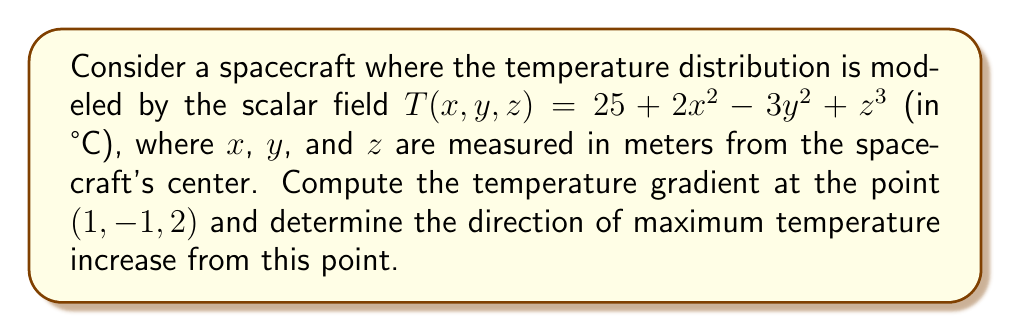Show me your answer to this math problem. To solve this problem, we'll follow these steps:

1) The gradient of a scalar field $T(x,y,z)$ is defined as:

   $$\nabla T = \left(\frac{\partial T}{\partial x}, \frac{\partial T}{\partial y}, \frac{\partial T}{\partial z}\right)$$

2) Let's compute each partial derivative:

   $$\frac{\partial T}{\partial x} = 4x$$
   $$\frac{\partial T}{\partial y} = -6y$$
   $$\frac{\partial T}{\partial z} = 3z^2$$

3) Now, we can form the gradient:

   $$\nabla T = (4x, -6y, 3z^2)$$

4) At the point (1, -1, 2), we have:

   $$\nabla T(1,-1,2) = (4(1), -6(-1), 3(2)^2) = (4, 6, 12)$$

5) This gradient vector points in the direction of maximum temperature increase. To get a unit vector in this direction, we normalize the gradient:

   $$\text{Direction} = \frac{\nabla T}{|\nabla T|} = \frac{(4, 6, 12)}{\sqrt{4^2 + 6^2 + 12^2}} = \frac{(4, 6, 12)}{\sqrt{196}} = \frac{(4, 6, 12)}{14}$$

6) Therefore, the direction of maximum temperature increase is $\frac{(4, 6, 12)}{14}$ or approximately (0.286, 0.429, 0.857).

As an aerospace engineer, it's crucial to understand temperature gradients for thermal management and material stress analysis. This gradient information can help in designing thermal control systems and selecting appropriate materials for different parts of the spacecraft.
Answer: $\nabla T(1,-1,2) = (4, 6, 12)$; Direction of max increase: $\frac{(4, 6, 12)}{14}$ 